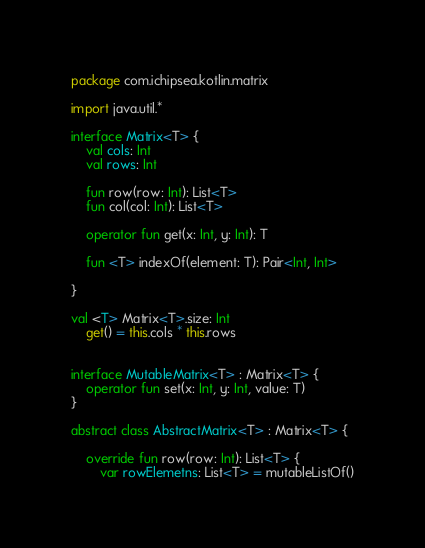<code> <loc_0><loc_0><loc_500><loc_500><_Kotlin_>package com.ichipsea.kotlin.matrix

import java.util.*

interface Matrix<T> {
    val cols: Int
    val rows: Int

    fun row(row: Int): List<T>
    fun col(col: Int): List<T>

    operator fun get(x: Int, y: Int): T

    fun <T> indexOf(element: T): Pair<Int, Int>

}

val <T> Matrix<T>.size: Int
    get() = this.cols * this.rows


interface MutableMatrix<T> : Matrix<T> {
    operator fun set(x: Int, y: Int, value: T)
}

abstract class AbstractMatrix<T> : Matrix<T> {

    override fun row(row: Int): List<T> {
        var rowElemetns: List<T> = mutableListOf()</code> 